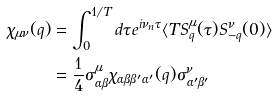Convert formula to latex. <formula><loc_0><loc_0><loc_500><loc_500>\chi _ { \mu \nu } ( q ) & = \int _ { 0 } ^ { 1 / T } d \tau e ^ { i \nu _ { n } \tau } \langle T S ^ { \mu } _ { q } ( \tau ) S ^ { \nu } _ { - q } ( 0 ) \rangle \\ & = \frac { 1 } { 4 } \sigma ^ { \mu } _ { \alpha \beta } \chi _ { \alpha \beta \beta ^ { \prime } \alpha ^ { \prime } } ( q ) \sigma ^ { \nu } _ { \alpha ^ { \prime } \beta ^ { \prime } }</formula> 